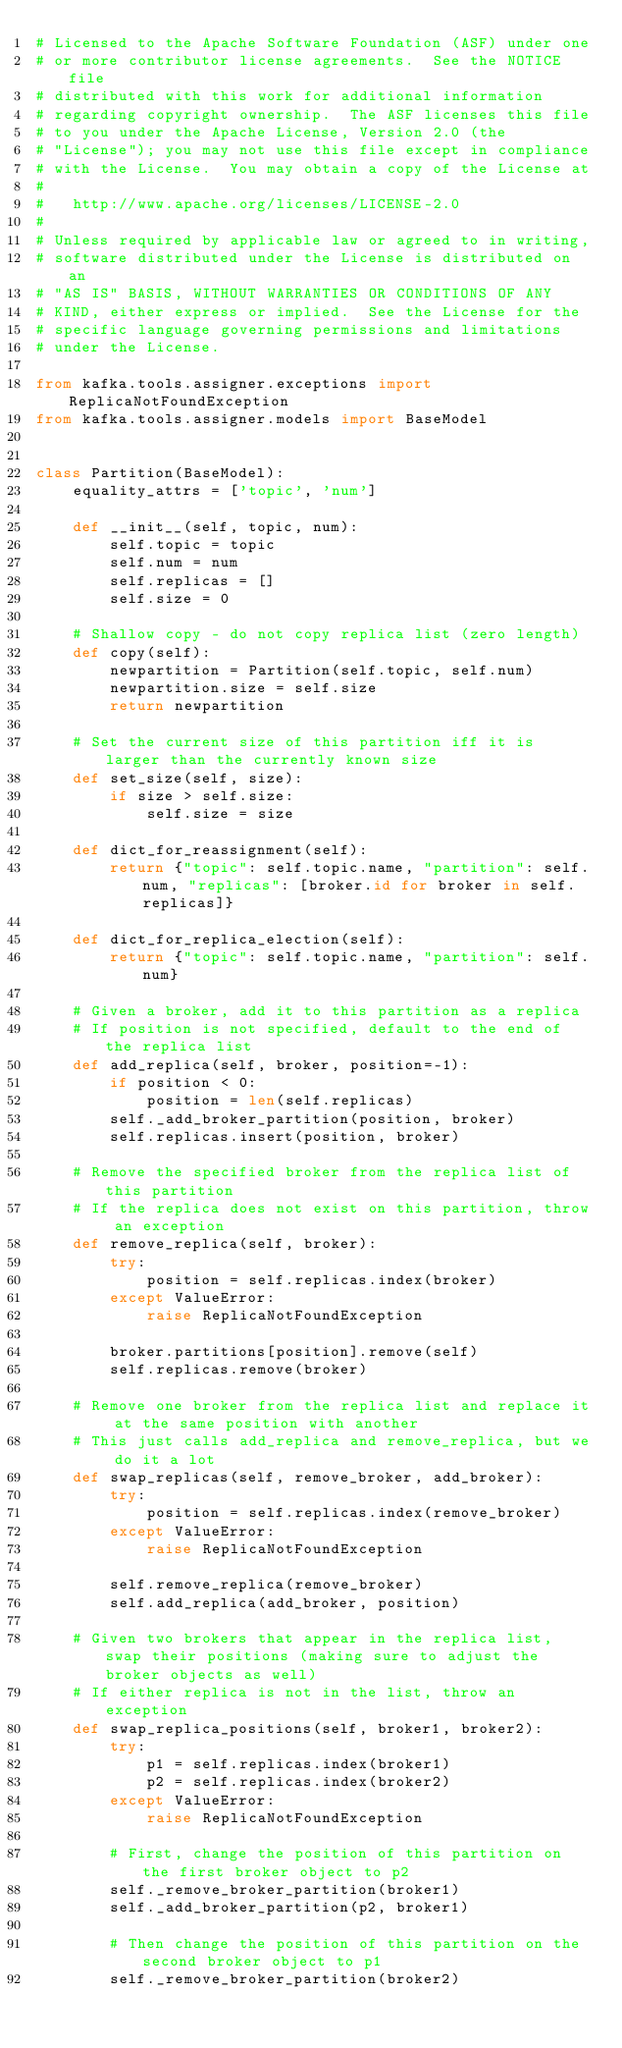<code> <loc_0><loc_0><loc_500><loc_500><_Python_># Licensed to the Apache Software Foundation (ASF) under one
# or more contributor license agreements.  See the NOTICE file
# distributed with this work for additional information
# regarding copyright ownership.  The ASF licenses this file
# to you under the Apache License, Version 2.0 (the
# "License"); you may not use this file except in compliance
# with the License.  You may obtain a copy of the License at
#
#   http://www.apache.org/licenses/LICENSE-2.0
#
# Unless required by applicable law or agreed to in writing,
# software distributed under the License is distributed on an
# "AS IS" BASIS, WITHOUT WARRANTIES OR CONDITIONS OF ANY
# KIND, either express or implied.  See the License for the
# specific language governing permissions and limitations
# under the License.

from kafka.tools.assigner.exceptions import ReplicaNotFoundException
from kafka.tools.assigner.models import BaseModel


class Partition(BaseModel):
    equality_attrs = ['topic', 'num']

    def __init__(self, topic, num):
        self.topic = topic
        self.num = num
        self.replicas = []
        self.size = 0

    # Shallow copy - do not copy replica list (zero length)
    def copy(self):
        newpartition = Partition(self.topic, self.num)
        newpartition.size = self.size
        return newpartition

    # Set the current size of this partition iff it is larger than the currently known size
    def set_size(self, size):
        if size > self.size:
            self.size = size

    def dict_for_reassignment(self):
        return {"topic": self.topic.name, "partition": self.num, "replicas": [broker.id for broker in self.replicas]}

    def dict_for_replica_election(self):
        return {"topic": self.topic.name, "partition": self.num}

    # Given a broker, add it to this partition as a replica
    # If position is not specified, default to the end of the replica list
    def add_replica(self, broker, position=-1):
        if position < 0:
            position = len(self.replicas)
        self._add_broker_partition(position, broker)
        self.replicas.insert(position, broker)

    # Remove the specified broker from the replica list of this partition
    # If the replica does not exist on this partition, throw an exception
    def remove_replica(self, broker):
        try:
            position = self.replicas.index(broker)
        except ValueError:
            raise ReplicaNotFoundException

        broker.partitions[position].remove(self)
        self.replicas.remove(broker)

    # Remove one broker from the replica list and replace it at the same position with another
    # This just calls add_replica and remove_replica, but we do it a lot
    def swap_replicas(self, remove_broker, add_broker):
        try:
            position = self.replicas.index(remove_broker)
        except ValueError:
            raise ReplicaNotFoundException

        self.remove_replica(remove_broker)
        self.add_replica(add_broker, position)

    # Given two brokers that appear in the replica list, swap their positions (making sure to adjust the broker objects as well)
    # If either replica is not in the list, throw an exception
    def swap_replica_positions(self, broker1, broker2):
        try:
            p1 = self.replicas.index(broker1)
            p2 = self.replicas.index(broker2)
        except ValueError:
            raise ReplicaNotFoundException

        # First, change the position of this partition on the first broker object to p2
        self._remove_broker_partition(broker1)
        self._add_broker_partition(p2, broker1)

        # Then change the position of this partition on the second broker object to p1
        self._remove_broker_partition(broker2)</code> 